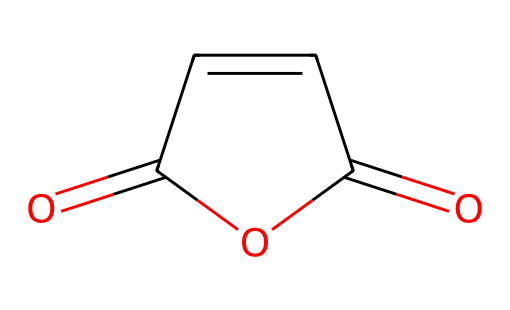What is the molecular formula of maleic anhydride? The molecular formula can be derived by counting the atoms from the SMILES representation. The structure depicts 4 carbon atoms, 2 oxygen atoms, and 4 hydrogen atoms, giving the formula C4H2O3.
Answer: C4H2O3 How many carbon atoms are present in maleic anhydride? From the provided SMILES structure, we can count the carbon atoms, which total 4.
Answer: 4 What type of functional groups are present in maleic anhydride? Analyzing the structure, we see that it contains both anhydride and alkene functional groups, as indicated by the two carbonyl (C=O) entities and a C=C double bond.
Answer: anhydride and alkene What is the characteristic feature of maleic anhydride that classifies it as an anhydride? The classification as an anhydride comes from the presence of the cyclic anhydride structure, which includes two carbonyl groups in a connected cyclic form, indicating that it derives from the dehydration of carboxylic acids.
Answer: cyclic structure How does the presence of the double bond influence the reactivity of maleic anhydride? The double bond (C=C) in the maleic anhydride makes it more reactive, especially in addition reactions, because the double bond can easily participate in such reactions, increasing its overall reactivity compared to its saturated counterparts.
Answer: increases reactivity What makes maleic anhydride suitable for use in automotive polymer coatings? Maleic anhydride’s reactivity with various polymers and its ability to enhance adhesion and durability of coatings make it suitable for automotive applications, contributing to the strength and longevity of the final product.
Answer: enhances adhesion and durability 